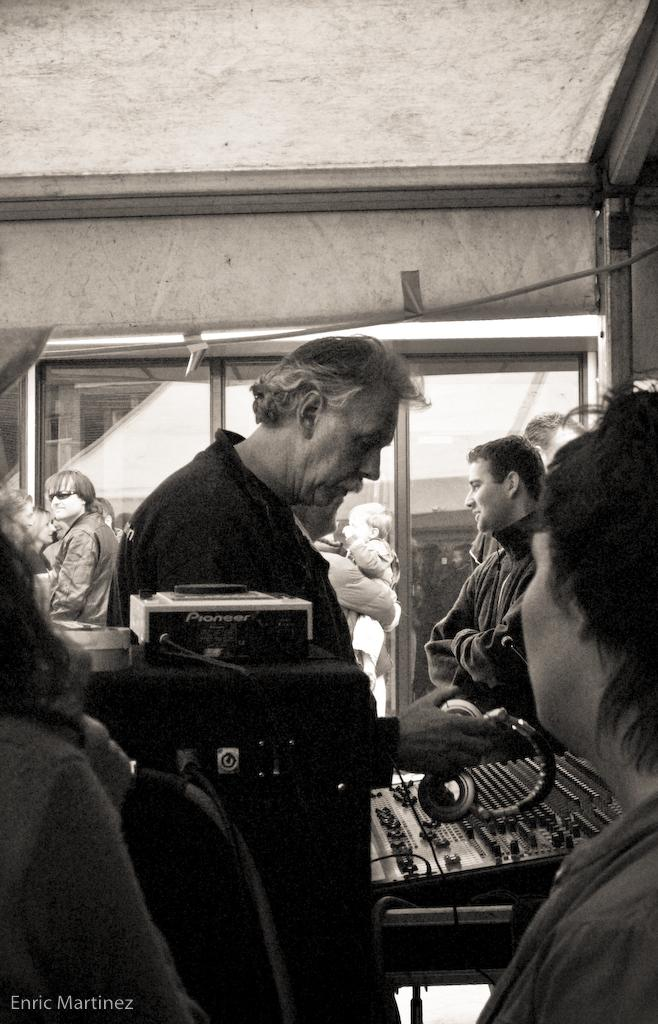What can be observed about the people in the image? There are people standing in the image. What is the man holding in the image? The man is holding headphones in the image. What device is present in the image related to music? There is a music system in the image. What color scheme is used in the image? The image is in black and white color. What is the income of the man's uncle in the image? There is no information about the man's uncle or his income in the image. 